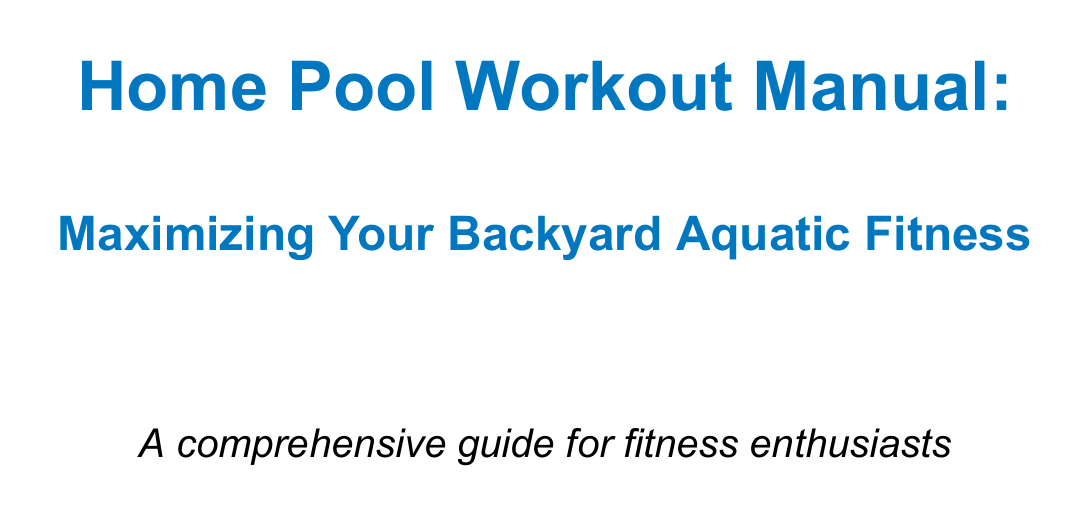What is the purpose of this manual? The purpose is to provide a comprehensive guide to utilizing your backyard swimming pool for effective workouts and water resistance training.
Answer: Comprehensive guide to utilizing your backyard swimming pool for effective workouts and water resistance training What are the benefits of pool workouts? The benefits are listed in the introduction section and include various aspects of fitness.
Answer: Low-impact exercise, full-body workout, improved cardiovascular health, enhanced flexibility and muscle strength, convenient home-based fitness solution How long should you perform freestyle swimming? The document specifies a range for the duration of freestyle swimming as part of cardio exercises.
Answer: 10-15 minutes What safety guideline mentions hydration? One of the safety guidelines emphasizes the importance of hydration during pool activities.
Answer: Stay hydrated How many repetitions of water push-ups should be performed? The strength training exercises section lists the number of repetitions for water push-ups.
Answer: 10 What equipment is suggested for added resistance? The equipment recommendations section lists items that are useful for enhancing workouts.
Answer: Aqua dumbbells How long is the "Cardio Burn" sample workout? The duration of the "Cardio Burn" workout is specified in the sample workout routines section.
Answer: 30 minutes What should be included when hosting pool workout sessions? The hosting tips section provides suggestions for enhancing guest experience during pool workouts.
Answer: Provide towels and water bottles for guests What is recommended to eat after a workout? The nutrition tips section advises on what to consume post-exercise for recovery.
Answer: A balanced meal within an hour after your workout to aid recovery 